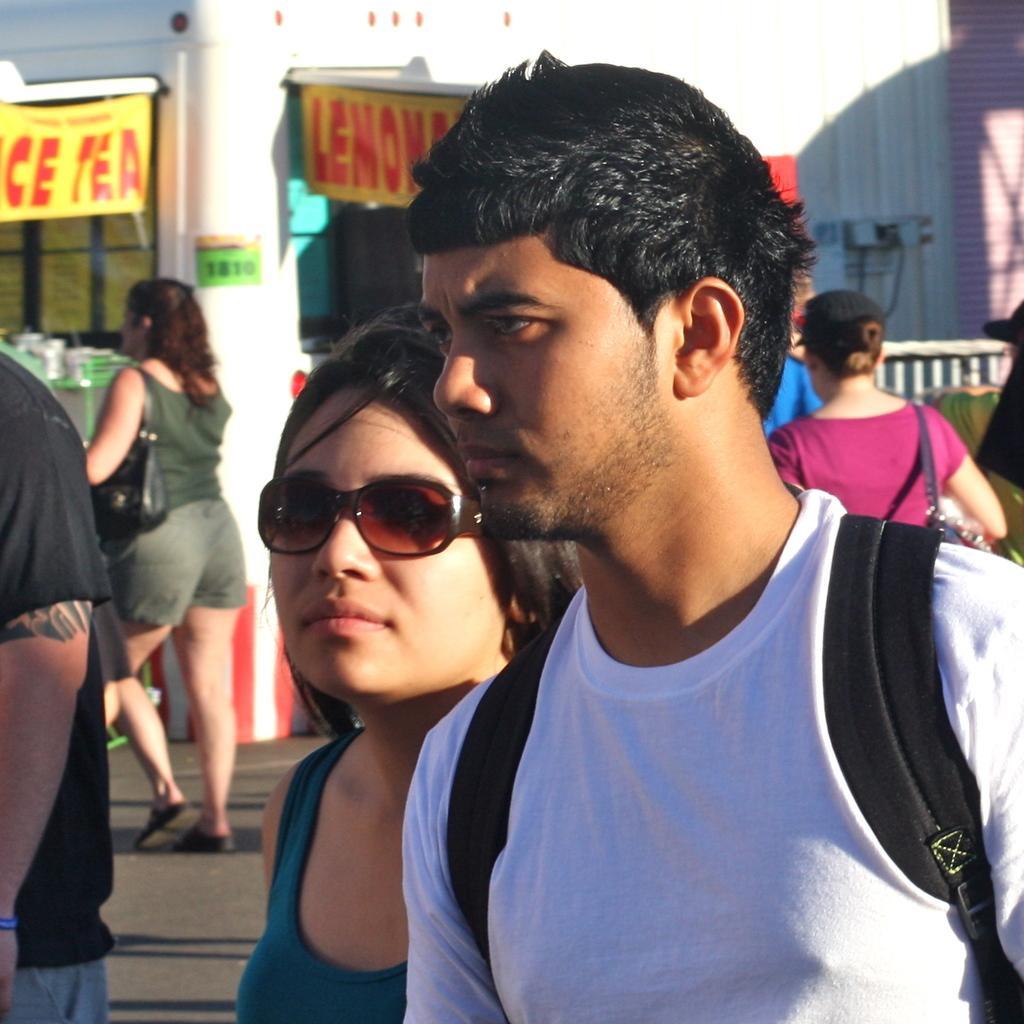Please provide a concise description of this image. In the given image i can see a people,banner and fence. 